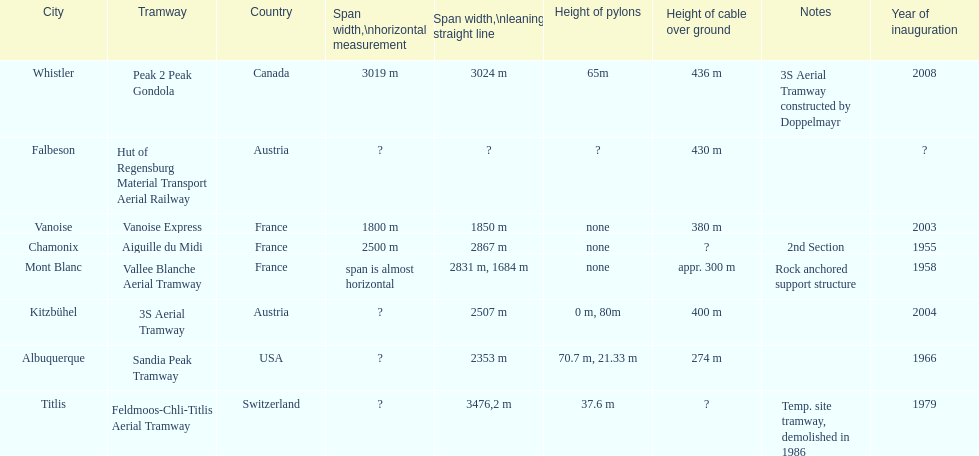Can you parse all the data within this table? {'header': ['City', 'Tramway', 'Country', 'Span width,\\nhorizontal measurement', 'Span\xa0width,\\nleaning straight line', 'Height of pylons', 'Height of cable over ground', 'Notes', 'Year of inauguration'], 'rows': [['Whistler', 'Peak 2 Peak Gondola', 'Canada', '3019 m', '3024 m', '65m', '436 m', '3S Aerial Tramway constructed by Doppelmayr', '2008'], ['Falbeson', 'Hut of Regensburg Material Transport Aerial Railway', 'Austria', '?', '?', '?', '430 m', '', '?'], ['Vanoise', 'Vanoise Express', 'France', '1800 m', '1850 m', 'none', '380 m', '', '2003'], ['Chamonix', 'Aiguille du Midi', 'France', '2500 m', '2867 m', 'none', '?', '2nd Section', '1955'], ['Mont Blanc', 'Vallee Blanche Aerial Tramway', 'France', 'span is almost horizontal', '2831 m, 1684 m', 'none', 'appr. 300 m', 'Rock anchored support structure', '1958'], ['Kitzbühel', '3S Aerial Tramway', 'Austria', '?', '2507 m', '0 m, 80m', '400 m', '', '2004'], ['Albuquerque', 'Sandia Peak Tramway', 'USA', '?', '2353 m', '70.7 m, 21.33 m', '274 m', '', '1966'], ['Titlis', 'Feldmoos-Chli-Titlis Aerial Tramway', 'Switzerland', '?', '3476,2 m', '37.6 m', '?', 'Temp. site tramway, demolished in 1986', '1979']]} Which tramway was built directly before the 3s aeriral tramway? Vanoise Express. 